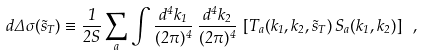Convert formula to latex. <formula><loc_0><loc_0><loc_500><loc_500>d \Delta \sigma ( \vec { s } _ { T } ) \equiv \frac { 1 } { 2 S } \sum _ { a } \int \frac { d ^ { 4 } k _ { 1 } } { ( 2 \pi ) ^ { 4 } } \, \frac { d ^ { 4 } k _ { 2 } } { ( 2 \pi ) ^ { 4 } } \, \left [ T _ { a } ( k _ { 1 } , k _ { 2 } , \vec { s } _ { T } ) \, S _ { a } ( k _ { 1 } , k _ { 2 } ) \right ] \ ,</formula> 